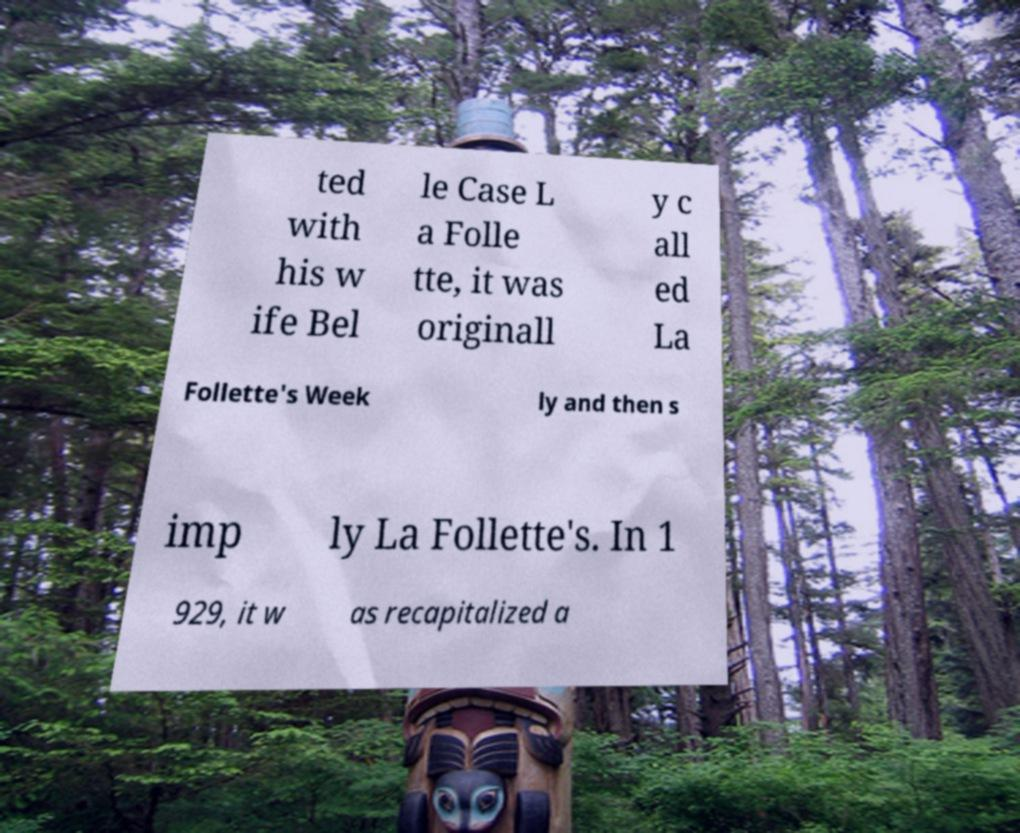I need the written content from this picture converted into text. Can you do that? ted with his w ife Bel le Case L a Folle tte, it was originall y c all ed La Follette's Week ly and then s imp ly La Follette's. In 1 929, it w as recapitalized a 